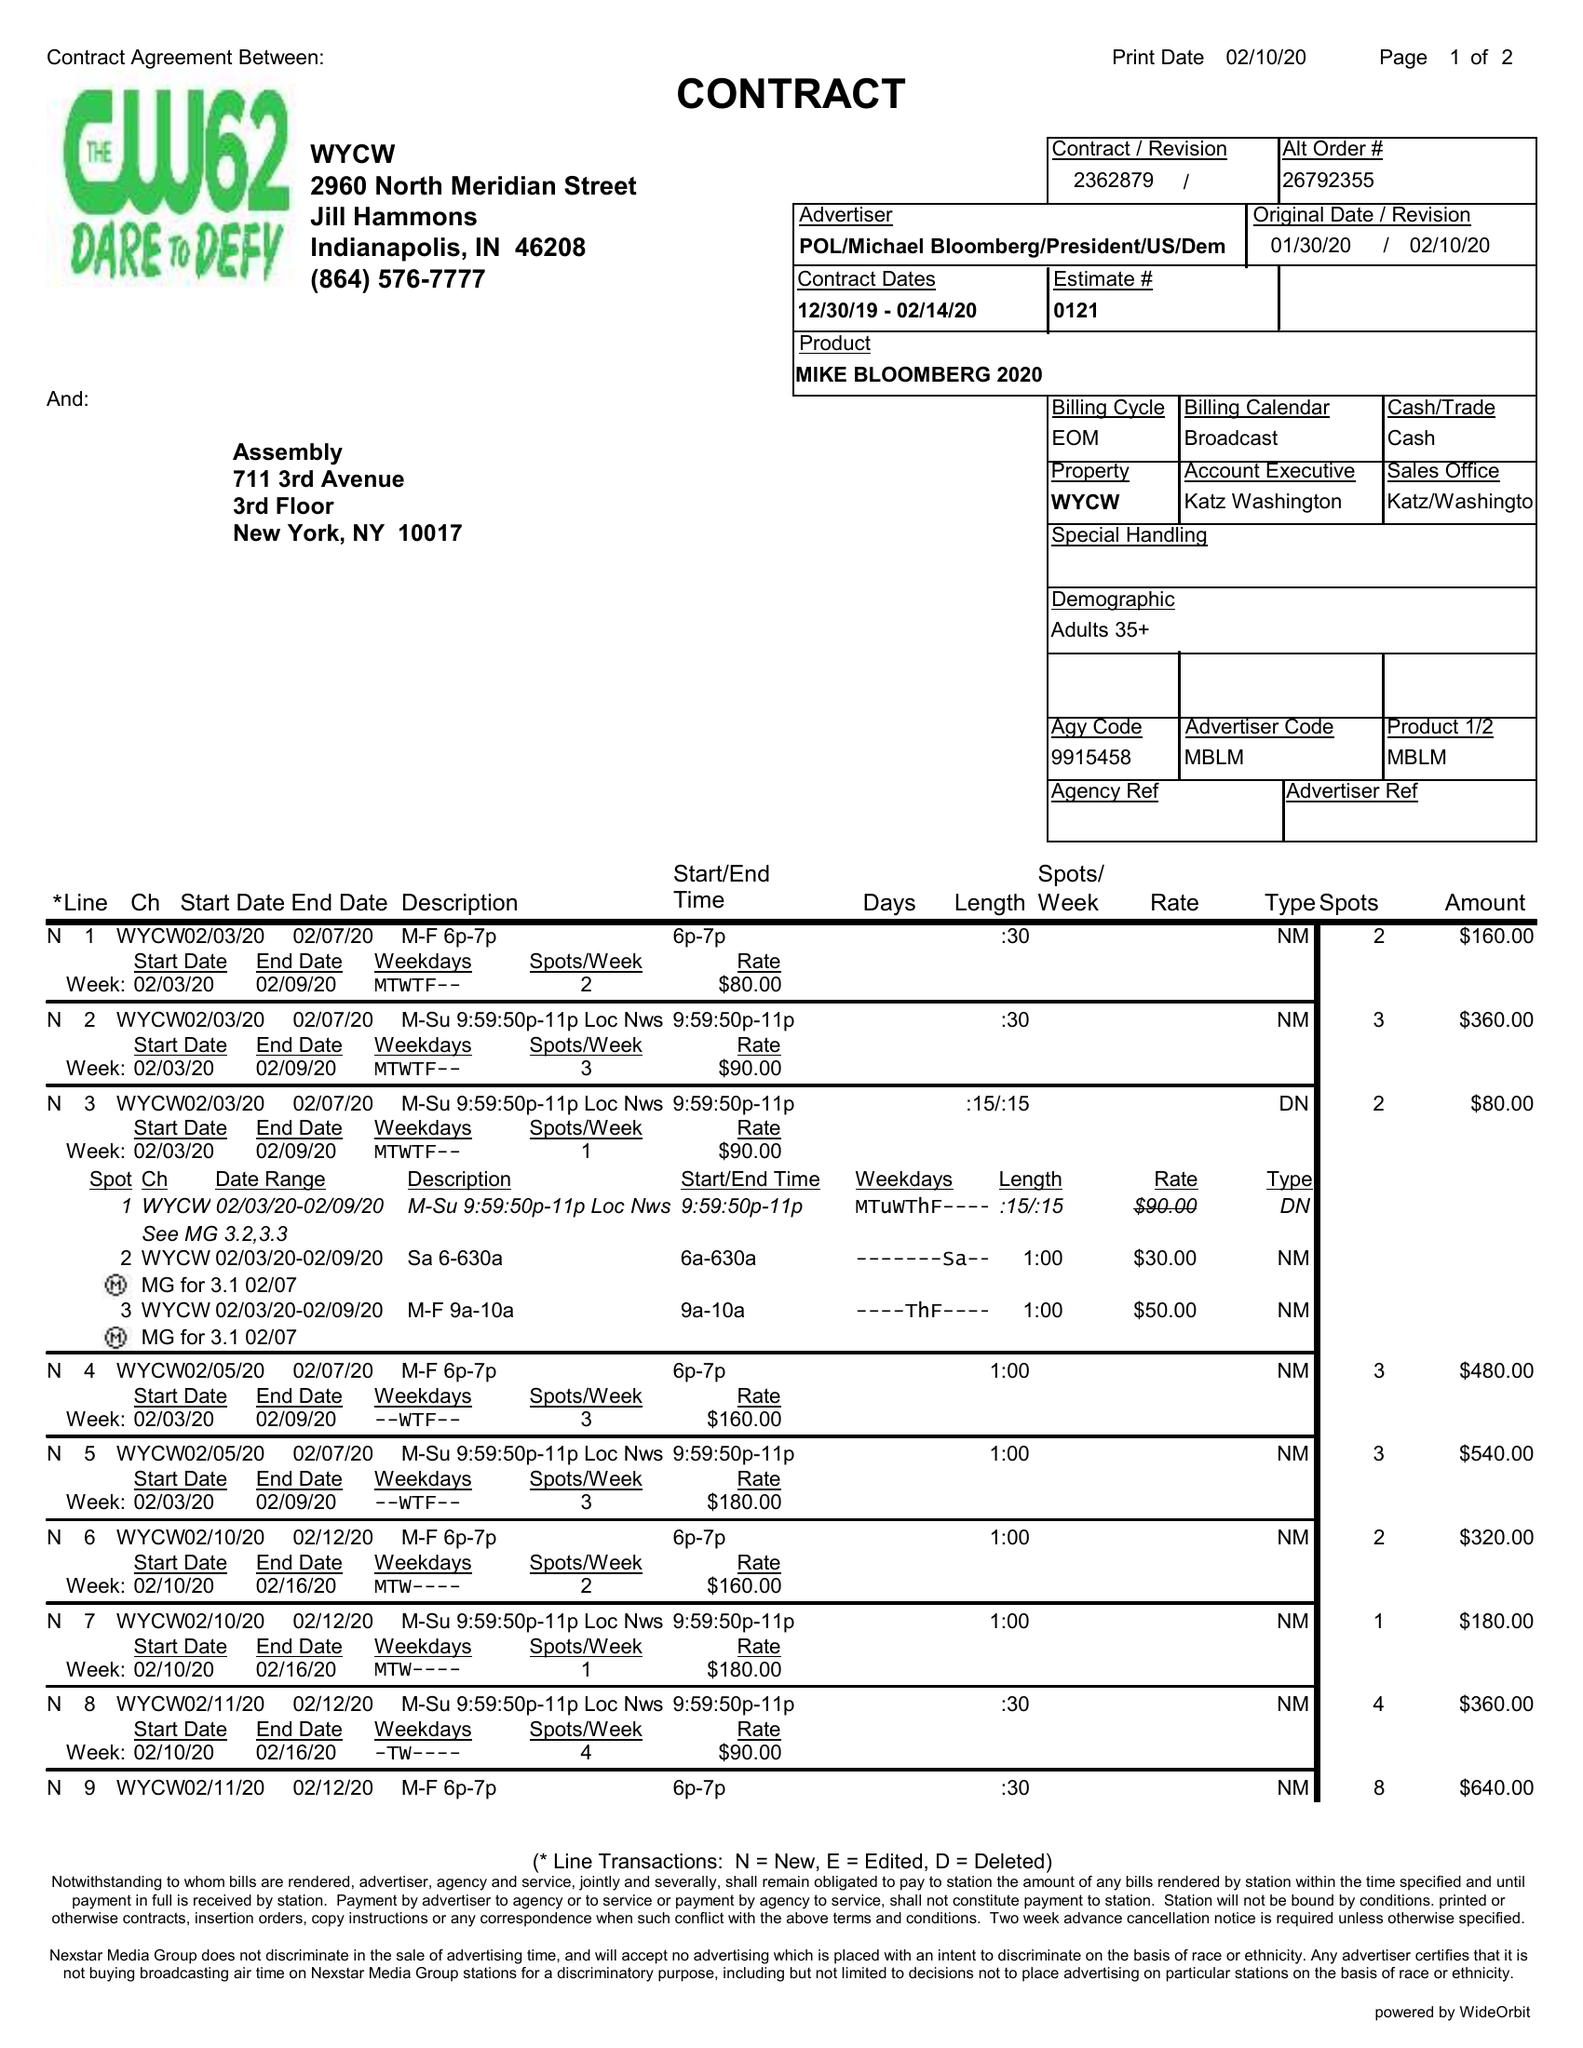What is the value for the contract_num?
Answer the question using a single word or phrase. 2362879 